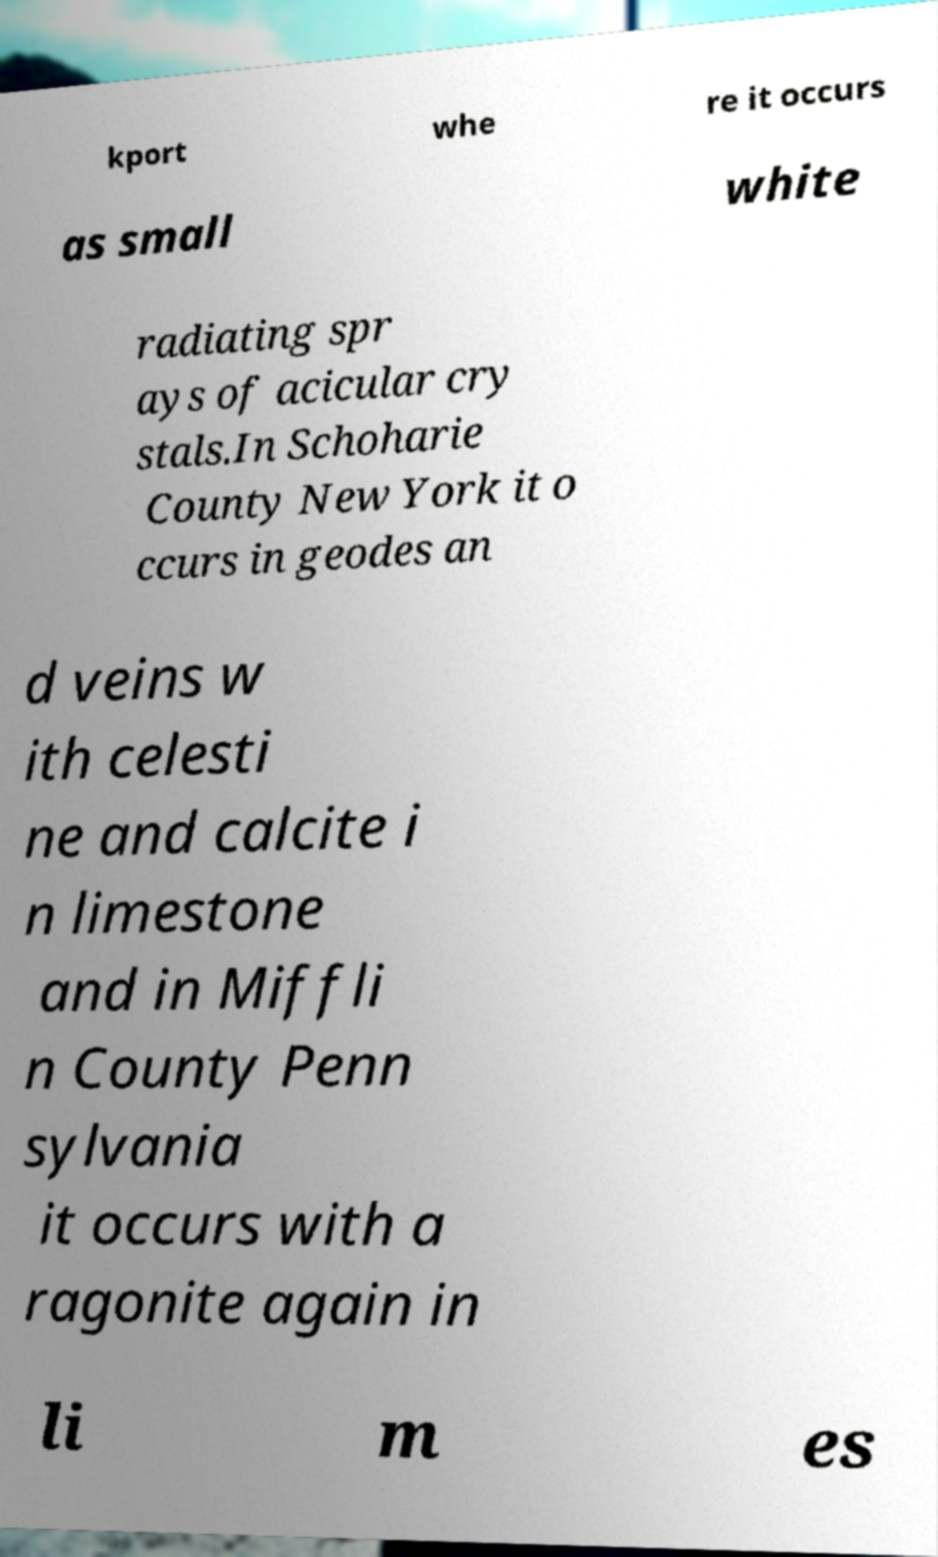Please identify and transcribe the text found in this image. kport whe re it occurs as small white radiating spr ays of acicular cry stals.In Schoharie County New York it o ccurs in geodes an d veins w ith celesti ne and calcite i n limestone and in Miffli n County Penn sylvania it occurs with a ragonite again in li m es 